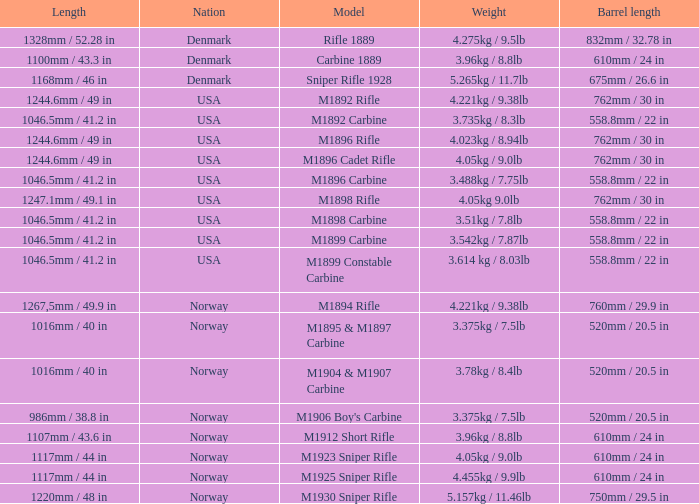What is Length, when Barrel Length is 750mm / 29.5 in? 1220mm / 48 in. 